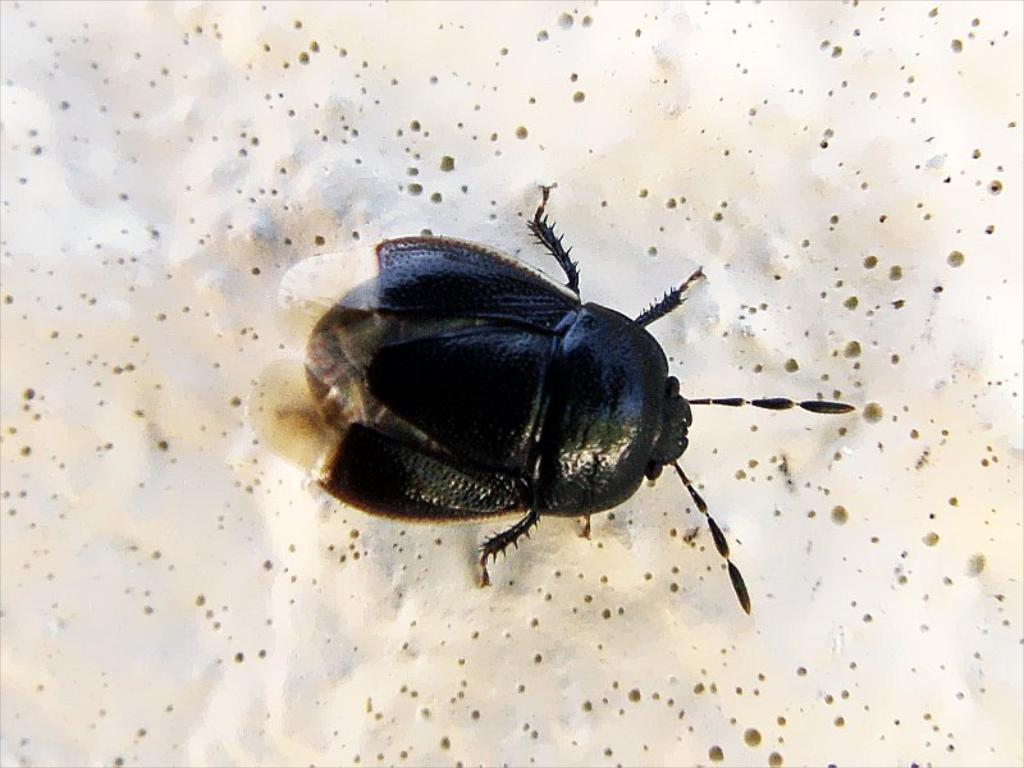What type of creature is in the picture? There is an insect in the picture. What are the main features of the insect? The insect has wings and a head. What is the background of the image? There is a white surface in the backdrop of the image. What type of rose can be seen in the image? There is no rose present in the image; it features an insect with wings and a head against a white background. How is the straw used in the image? There is no straw present in the image. 